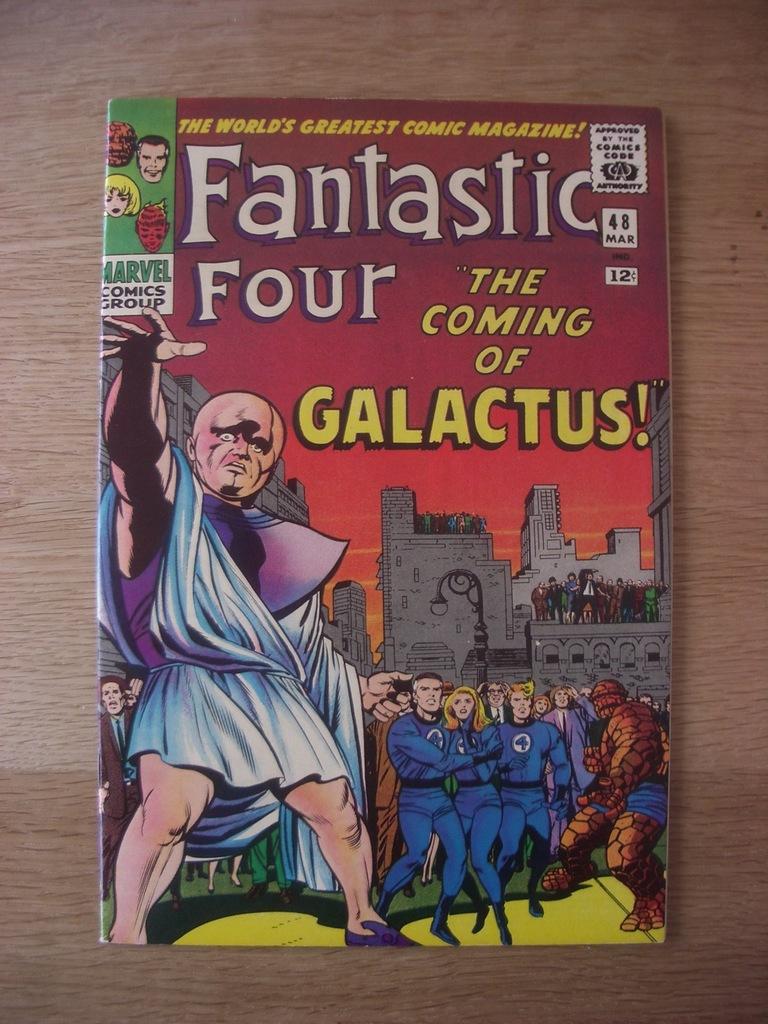Which comic group made this?
Ensure brevity in your answer.  Marvel. 